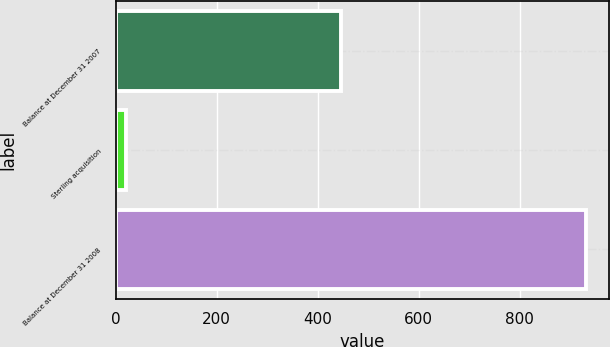Convert chart to OTSL. <chart><loc_0><loc_0><loc_500><loc_500><bar_chart><fcel>Balance at December 31 2007<fcel>Sterling acquisition<fcel>Balance at December 31 2008<nl><fcel>445<fcel>21<fcel>930<nl></chart> 